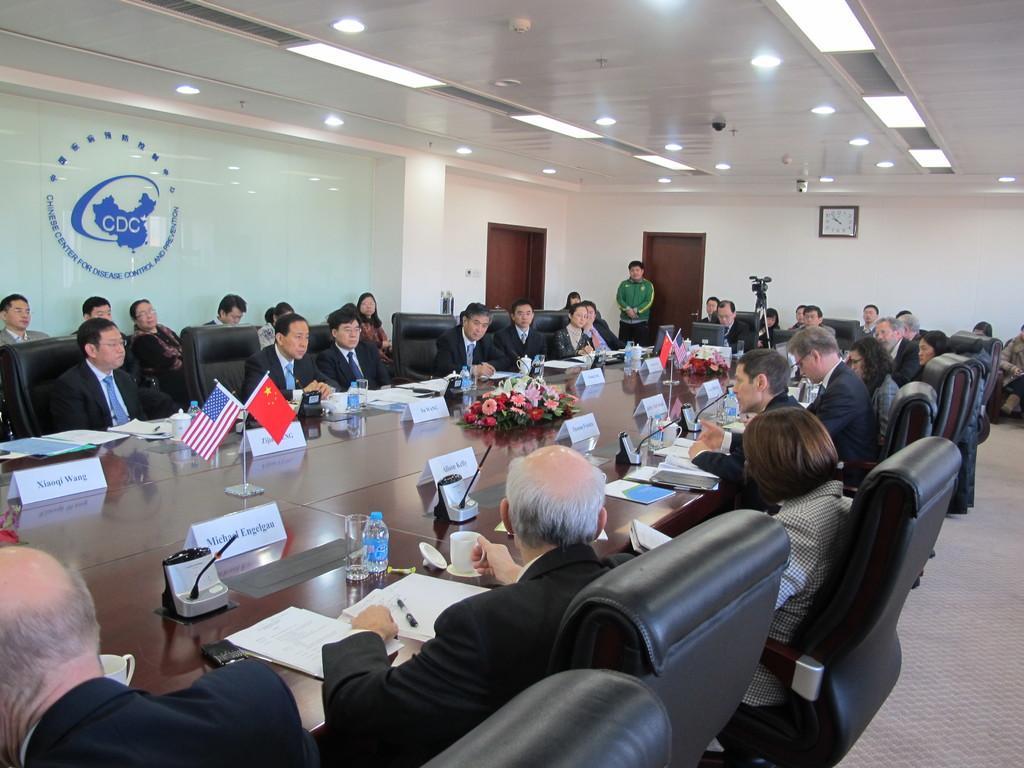Can you describe this image briefly? There are any people in the room. Most of them are sitting on chairs. In the middle on a table there are name plates, mics, flowers, flags, cups, bottles, glasses, papers, pen and few other things are there. On the ceiling there are lights. Here there is a clock. Two persons are standing here. These are doors. This is a glass wall. 